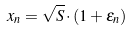<formula> <loc_0><loc_0><loc_500><loc_500>x _ { n } = \sqrt { S } \cdot ( 1 + \epsilon _ { n } )</formula> 